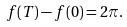<formula> <loc_0><loc_0><loc_500><loc_500>f ( T ) - f ( 0 ) = 2 \pi .</formula> 